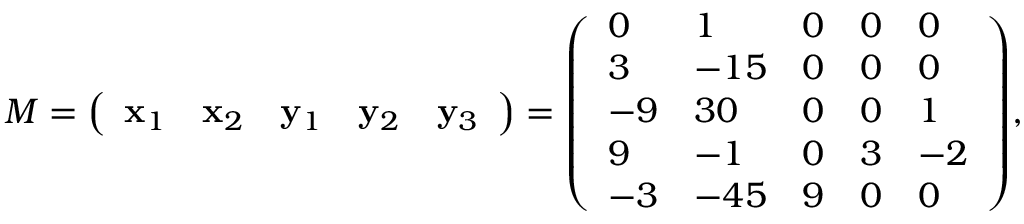Convert formula to latex. <formula><loc_0><loc_0><loc_500><loc_500>M = { \left ( \begin{array} { l l l l l } { x _ { 1 } } & { x _ { 2 } } & { y _ { 1 } } & { y _ { 2 } } & { y _ { 3 } } \end{array} \right ) } = { \left ( \begin{array} { l l l l l } { 0 } & { 1 } & { 0 } & { 0 } & { 0 } \\ { 3 } & { - 1 5 } & { 0 } & { 0 } & { 0 } \\ { - 9 } & { 3 0 } & { 0 } & { 0 } & { 1 } \\ { 9 } & { - 1 } & { 0 } & { 3 } & { - 2 } \\ { - 3 } & { - 4 5 } & { 9 } & { 0 } & { 0 } \end{array} \right ) } ,</formula> 